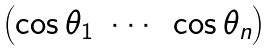<formula> <loc_0><loc_0><loc_500><loc_500>\begin{pmatrix} \cos { \theta _ { 1 } } & \cdots & \cos { \theta _ { n } } \end{pmatrix}</formula> 